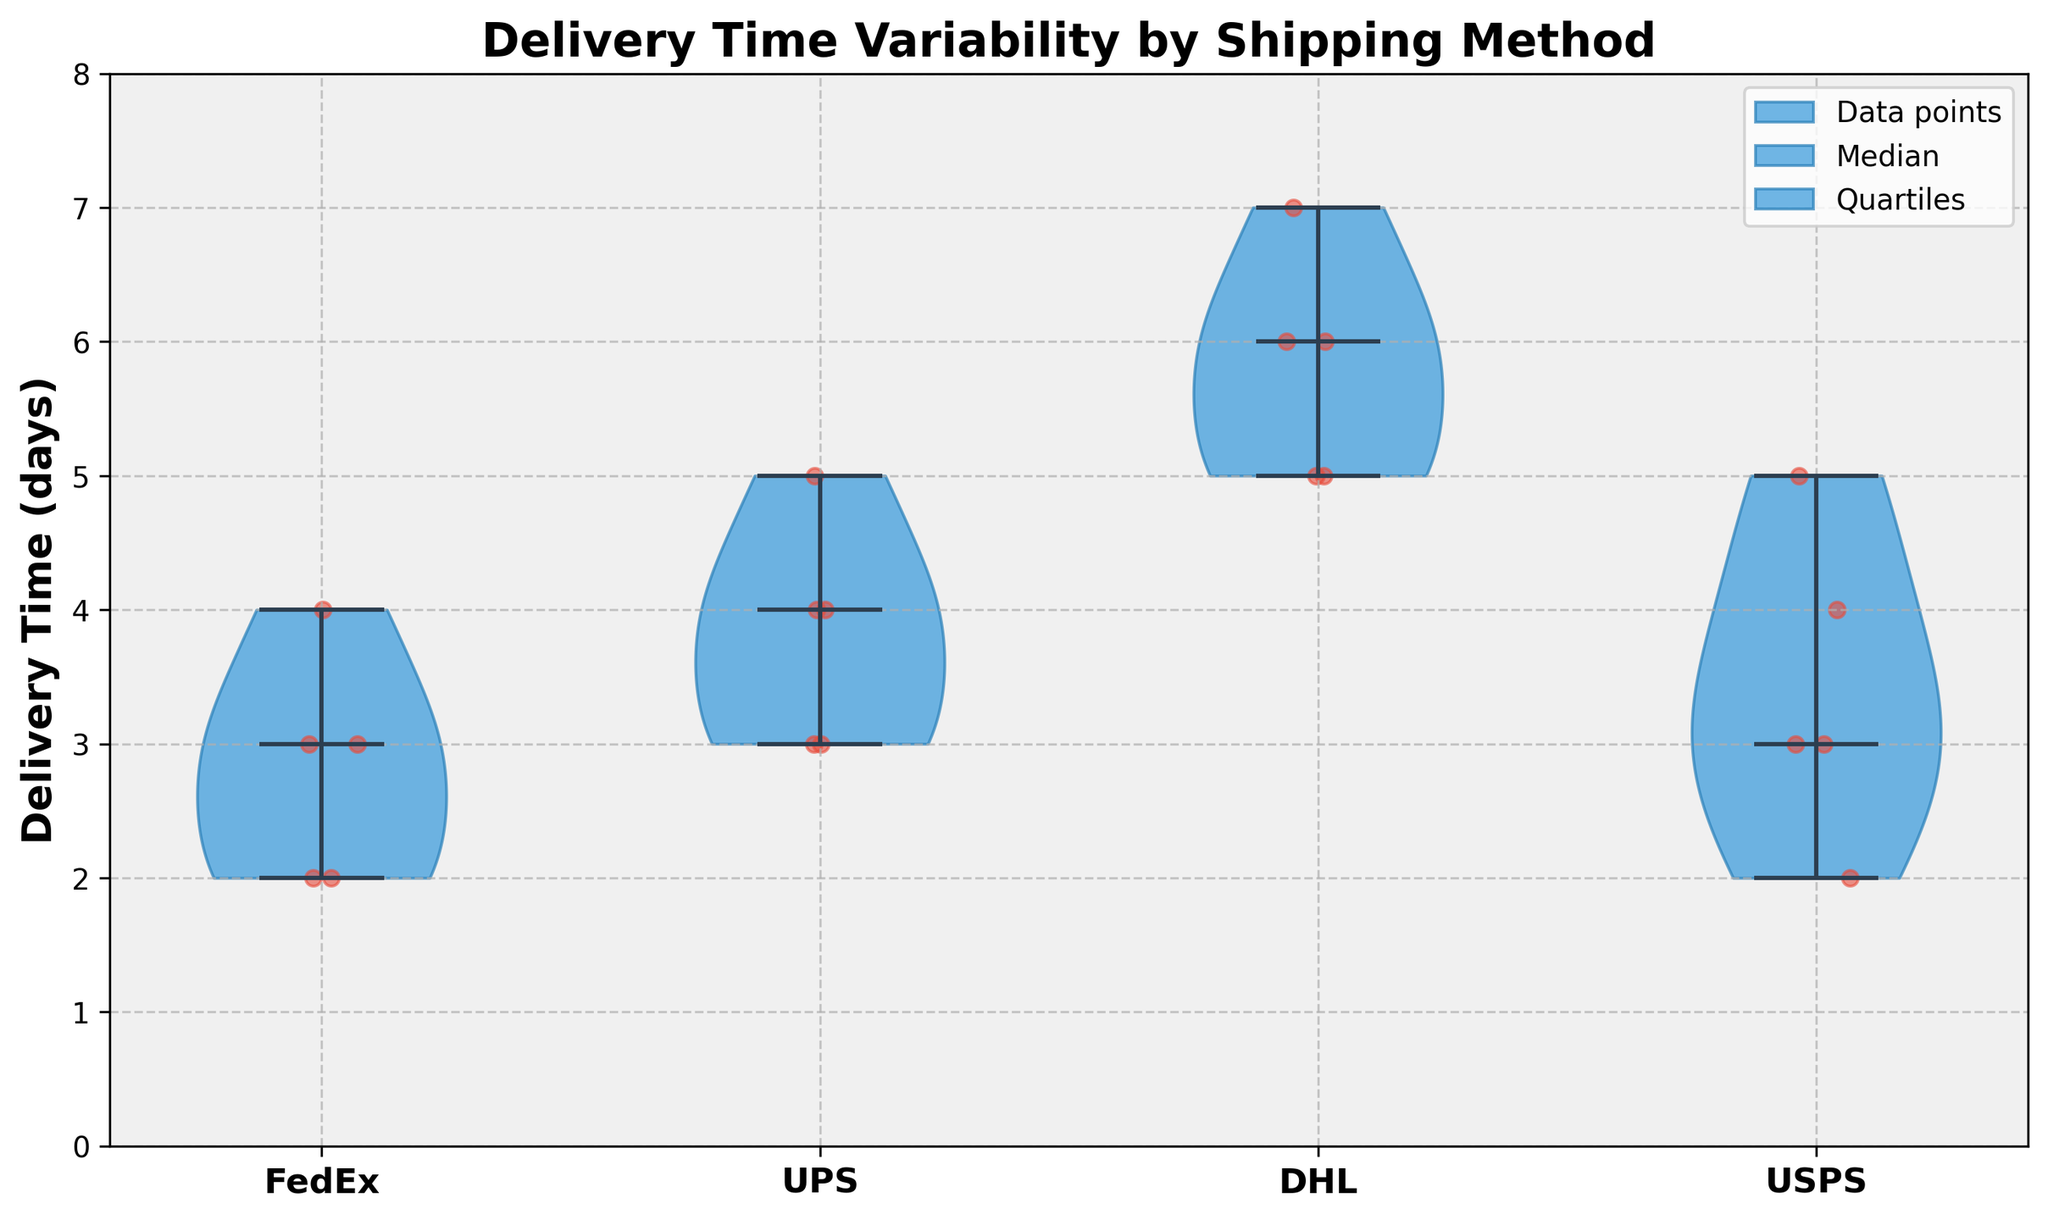What's the title of the figure? The title is typically found at the top of the figure and is meant to describe the main focus or subject of the visualization.
Answer: Delivery Time Variability by Shipping Method What does the y-axis of the figure represent? The y-axis label describes the variable being measured, in this case, it indicates the time taken for delivery in days.
Answer: Delivery Time (days) Which shipping method shows the highest median delivery time? To determine this, you need to identify which violin plot's center line (median) lies at the highest point on the y-axis.
Answer: DHL How many days does the median delivery time for USPS span? You should locate the center of the USPS violin plot and note the value on the y-axis corresponding to the median.
Answer: 3 Which shipping method has the widest range of delivery times? The range is the difference between the maximum and minimum values in a violin plot; look for the widest span from top to bottom.
Answer: DHL Compare the variability of delivery times between FedEx and USPS. Which one is more variable and why? Variability can be assessed by the shape and width of the violin plots; a wider spread indicates more variability. DHL's plot is more spread out vertically and horizontally than USPS'.
Answer: DHL; it has a wider spread What is the approximate range of delivery times for UPS? Check the top and bottom points of the UPS violin plot to find the range of delivery times.
Answer: 3 to 5 days Which shipping methods have overlapping delivery time ranges? Look for areas where the violin plots' distributions overlap along the y-axis.
Answer: FedEx, USPS, and UPS What distinctive visual element represents the median in each violin plot? Identify the common visual feature that indicates the median value in the plots.
Answer: A horizontal line inside each violin plot 